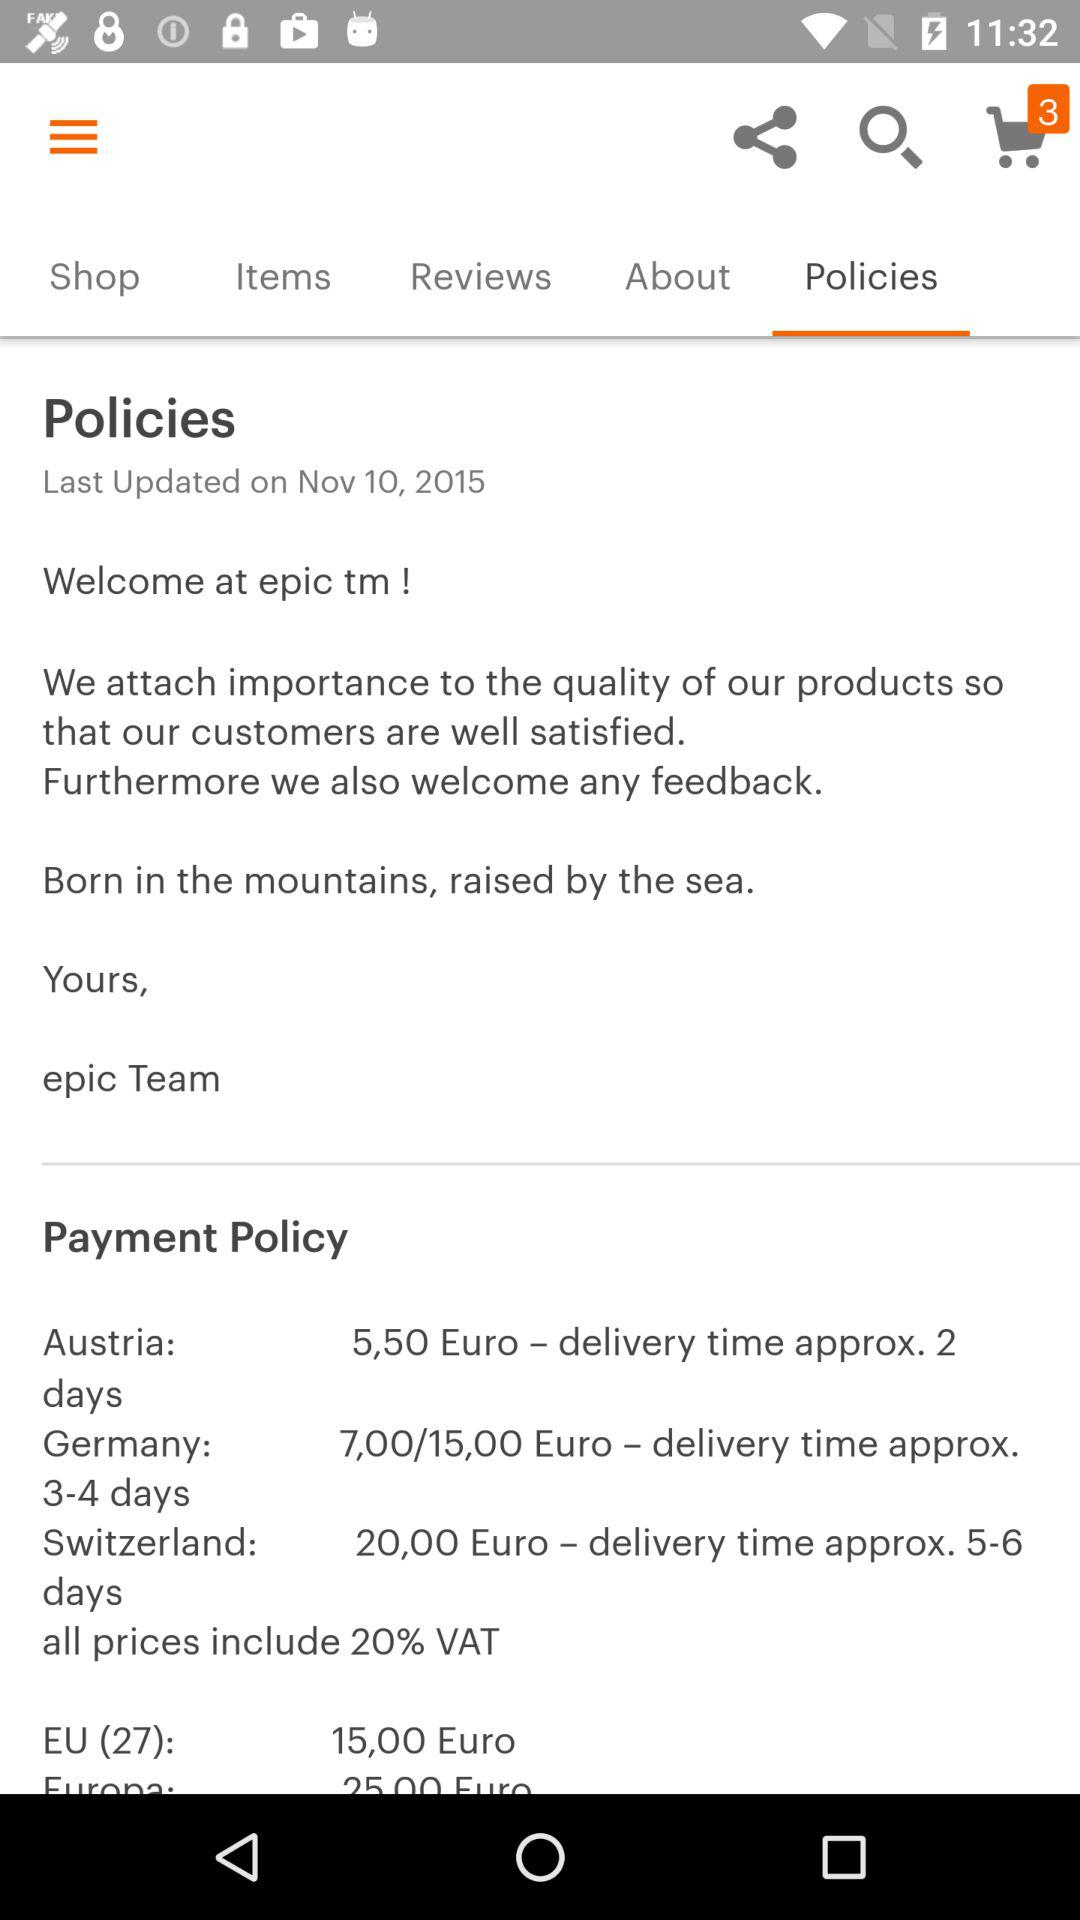What are the payment policy days for Switzerland?
When the provided information is insufficient, respond with <no answer>. <no answer> 